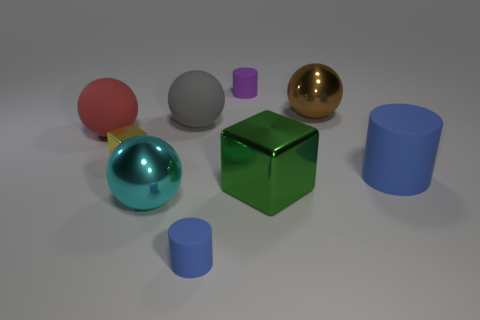Subtract all brown spheres. How many spheres are left? 3 Subtract all brown balls. How many blue cylinders are left? 2 Subtract all red spheres. How many spheres are left? 3 Subtract 2 balls. How many balls are left? 2 Subtract all blocks. How many objects are left? 7 Subtract all brown cylinders. Subtract all blue balls. How many cylinders are left? 3 Subtract 1 gray balls. How many objects are left? 8 Subtract all large green metal objects. Subtract all tiny blocks. How many objects are left? 7 Add 8 purple matte cylinders. How many purple matte cylinders are left? 9 Add 3 big red metal things. How many big red metal things exist? 3 